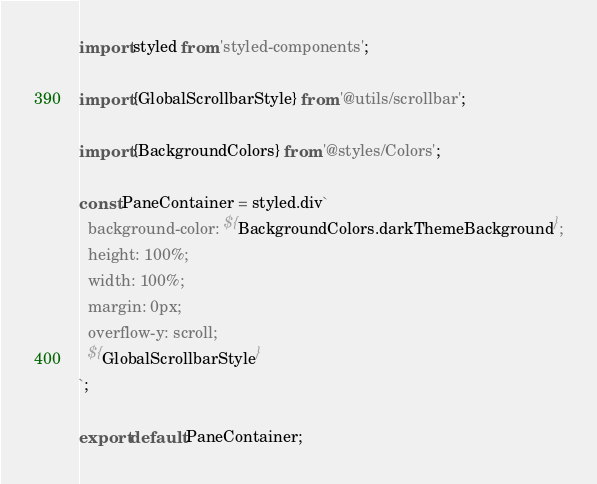Convert code to text. <code><loc_0><loc_0><loc_500><loc_500><_TypeScript_>import styled from 'styled-components';

import {GlobalScrollbarStyle} from '@utils/scrollbar';

import {BackgroundColors} from '@styles/Colors';

const PaneContainer = styled.div`
  background-color: ${BackgroundColors.darkThemeBackground};
  height: 100%;
  width: 100%;
  margin: 0px;
  overflow-y: scroll;
  ${GlobalScrollbarStyle}
`;

export default PaneContainer;
</code> 